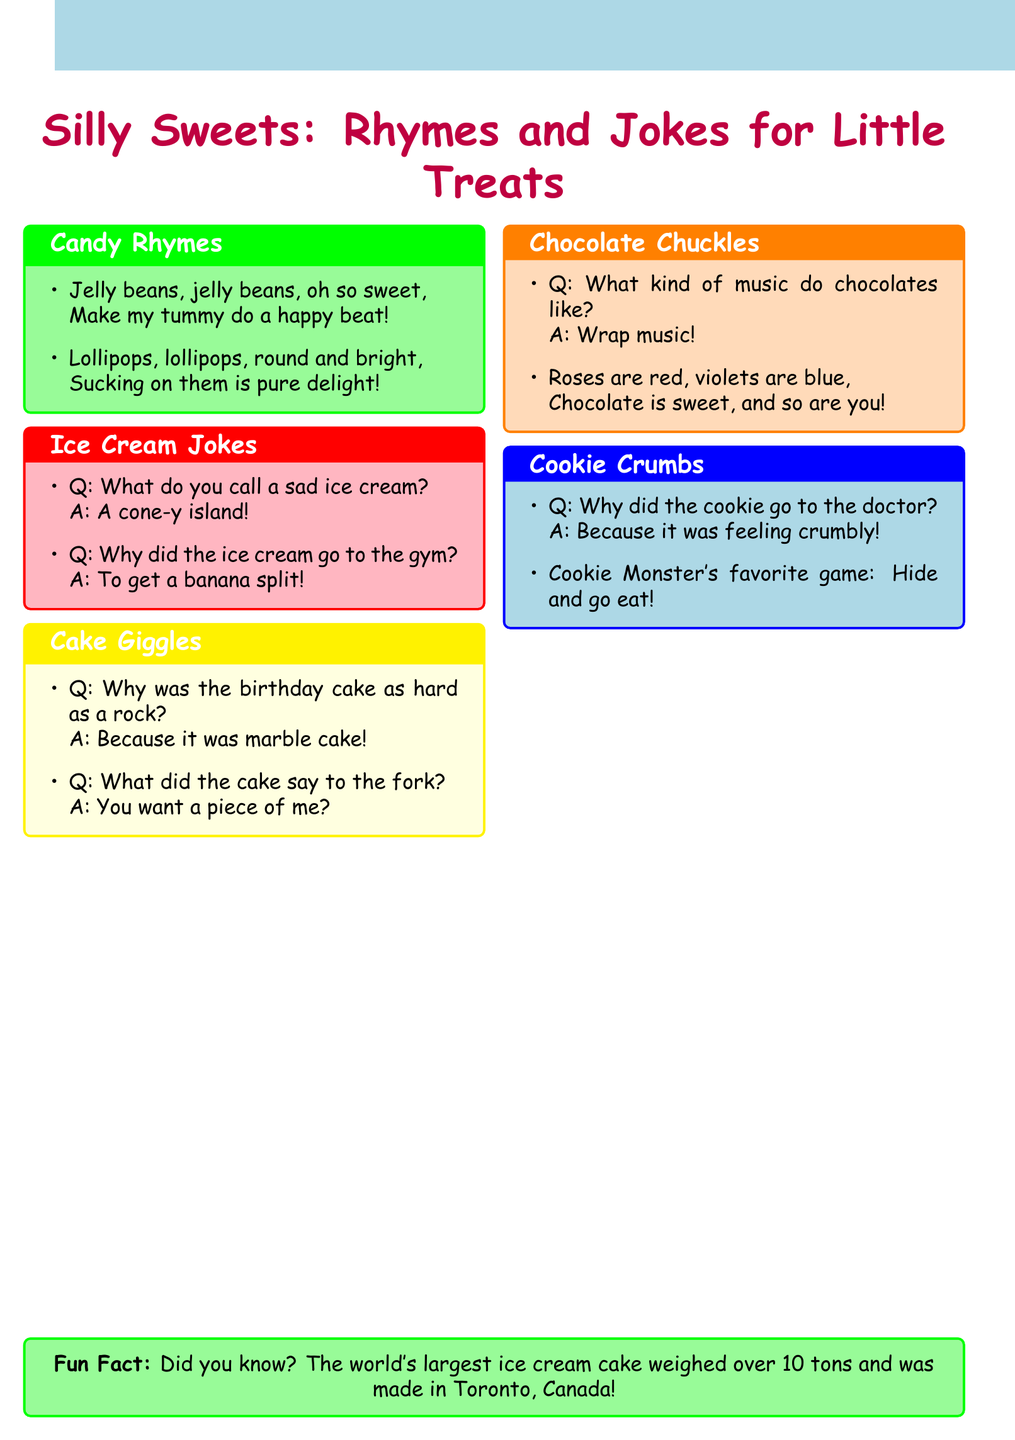What is the title of the document? The title can be found at the top of the document, indicating the main subject of the collection.
Answer: Silly Sweets: Rhymes and Jokes for Little Treats How many sections are in the document? The number of sections can be counted in the content provided, each section has a unique name.
Answer: 5 What dessert is mentioned in the joke about being sad? This specific joke can be found in the Ice Cream Jokes section, directly referring to the dessert in question.
Answer: ice cream Which candy is described in a rhyme about making a tummy beat? This rhyme is located in the Candy Rhymes section, referencing a type of candy specifically.
Answer: jelly beans What is the fun fact mentioned at the end of the document? The fun fact is positioned in a specific box at the bottom, providing a piece of trivia related to ice cream.
Answer: The world's largest ice cream cake weighed over 10 tons and was made in Toronto, Canada! 